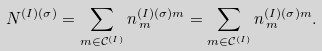<formula> <loc_0><loc_0><loc_500><loc_500>N ^ { ( I ) ( \sigma ) } = \sum _ { m \in \mathcal { C } ^ { ( I ) } } n ^ { ( I ) ( \sigma ) m } _ { \, m } = \sum _ { m \in \mathcal { C } ^ { ( I ) } } n ^ { ( I ) ( \sigma ) m } _ { \, m } .</formula> 